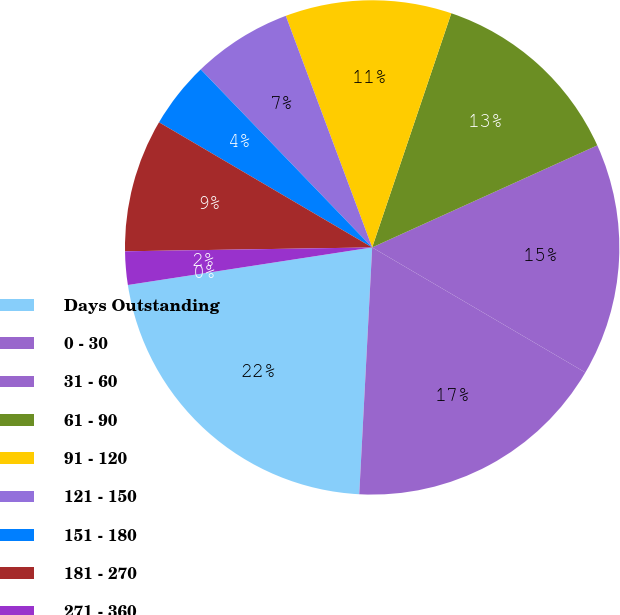Convert chart to OTSL. <chart><loc_0><loc_0><loc_500><loc_500><pie_chart><fcel>Days Outstanding<fcel>0 - 30<fcel>31 - 60<fcel>61 - 90<fcel>91 - 120<fcel>121 - 150<fcel>151 - 180<fcel>181 - 270<fcel>271 - 360<fcel>Over 360<nl><fcel>21.74%<fcel>17.39%<fcel>15.22%<fcel>13.04%<fcel>10.87%<fcel>6.52%<fcel>4.35%<fcel>8.7%<fcel>2.18%<fcel>0.0%<nl></chart> 